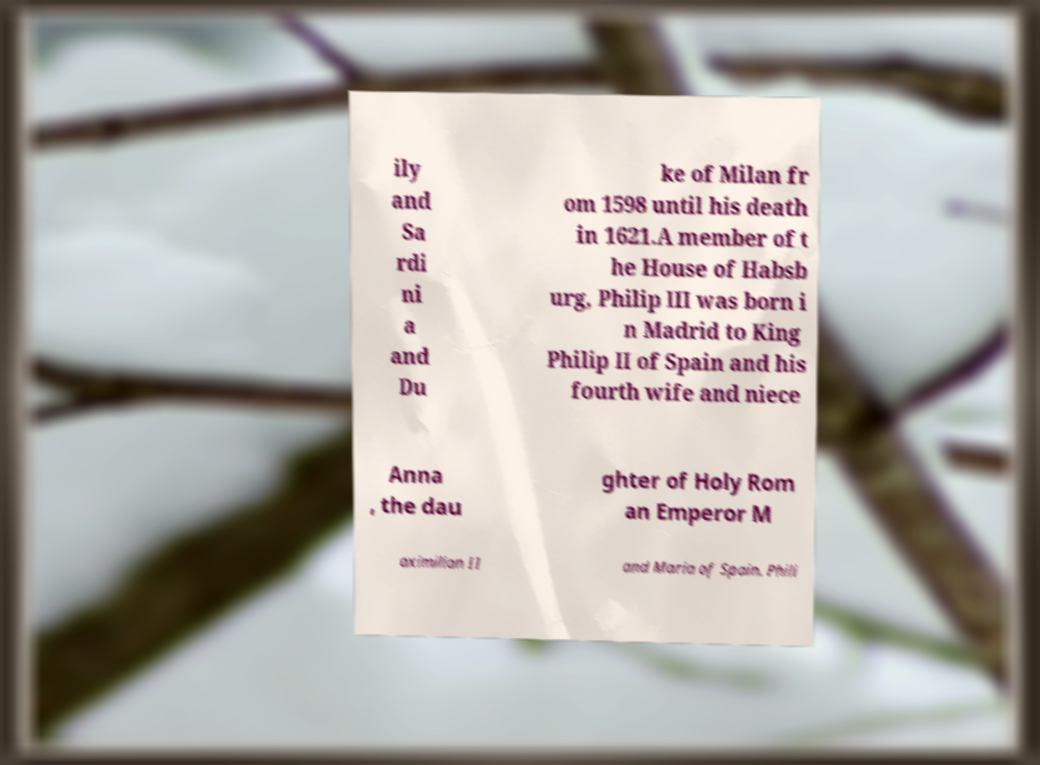Could you assist in decoding the text presented in this image and type it out clearly? ily and Sa rdi ni a and Du ke of Milan fr om 1598 until his death in 1621.A member of t he House of Habsb urg, Philip III was born i n Madrid to King Philip II of Spain and his fourth wife and niece Anna , the dau ghter of Holy Rom an Emperor M aximilian II and Maria of Spain. Phili 